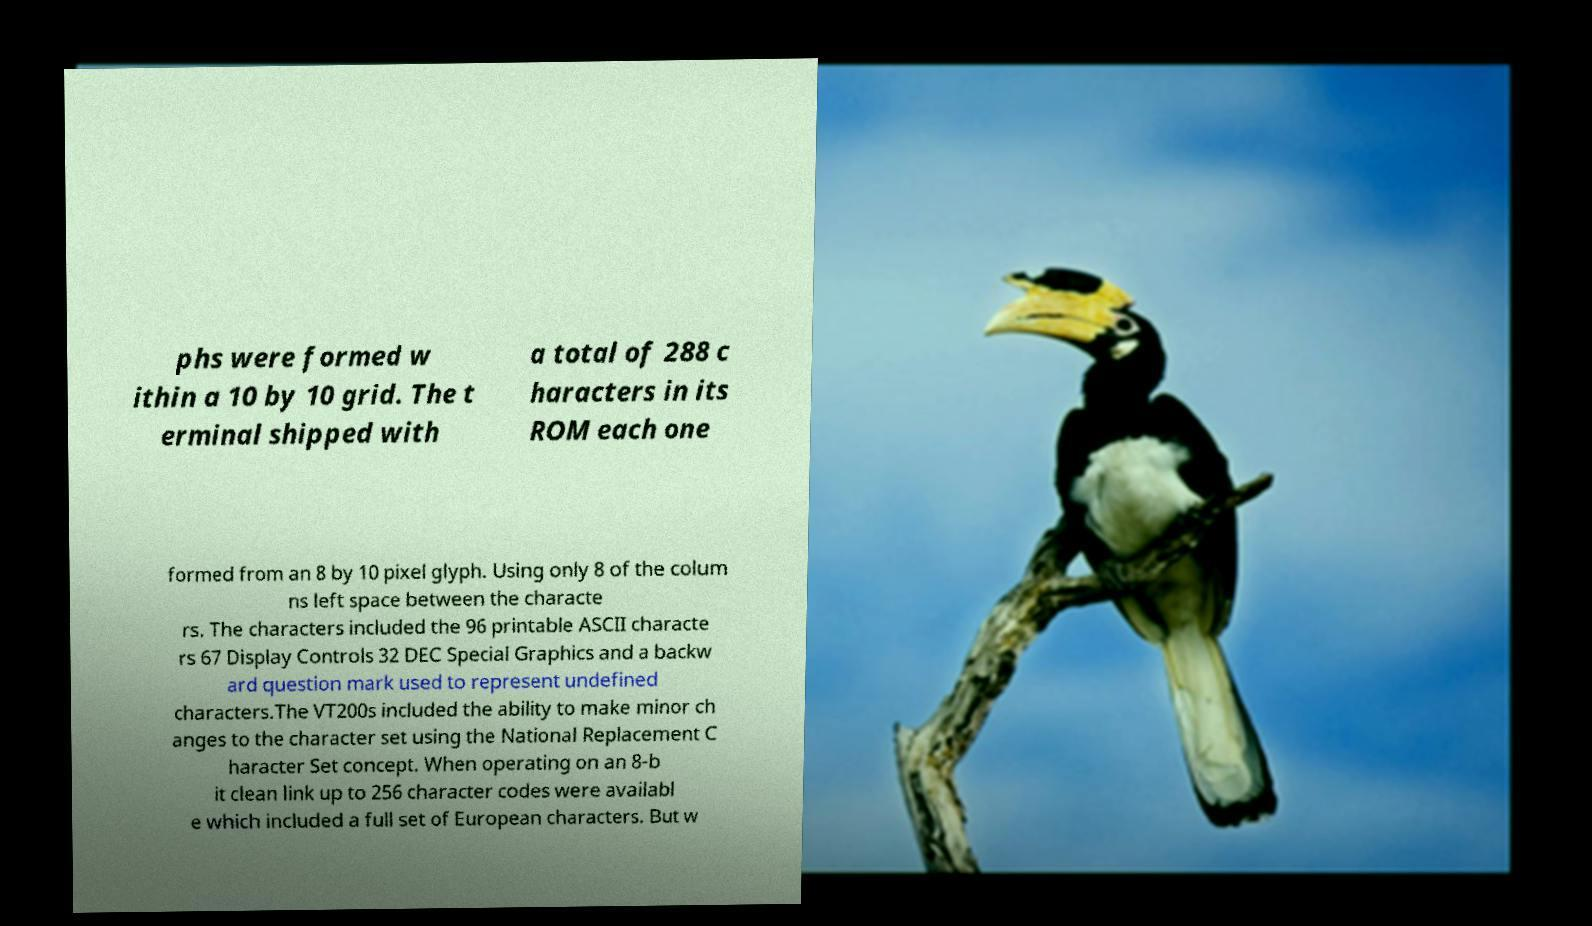I need the written content from this picture converted into text. Can you do that? phs were formed w ithin a 10 by 10 grid. The t erminal shipped with a total of 288 c haracters in its ROM each one formed from an 8 by 10 pixel glyph. Using only 8 of the colum ns left space between the characte rs. The characters included the 96 printable ASCII characte rs 67 Display Controls 32 DEC Special Graphics and a backw ard question mark used to represent undefined characters.The VT200s included the ability to make minor ch anges to the character set using the National Replacement C haracter Set concept. When operating on an 8-b it clean link up to 256 character codes were availabl e which included a full set of European characters. But w 